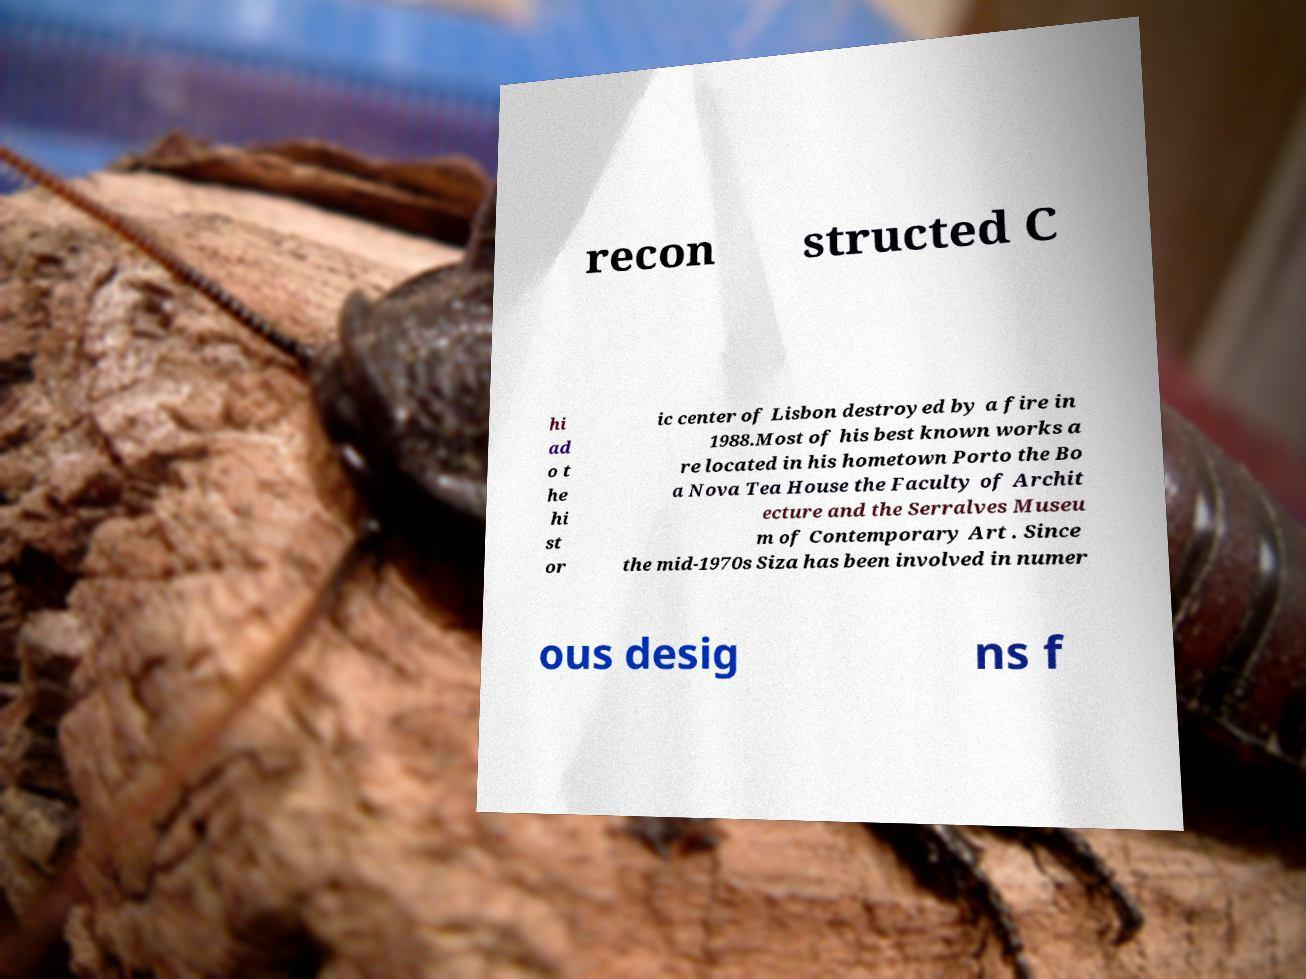Please identify and transcribe the text found in this image. recon structed C hi ad o t he hi st or ic center of Lisbon destroyed by a fire in 1988.Most of his best known works a re located in his hometown Porto the Bo a Nova Tea House the Faculty of Archit ecture and the Serralves Museu m of Contemporary Art . Since the mid-1970s Siza has been involved in numer ous desig ns f 